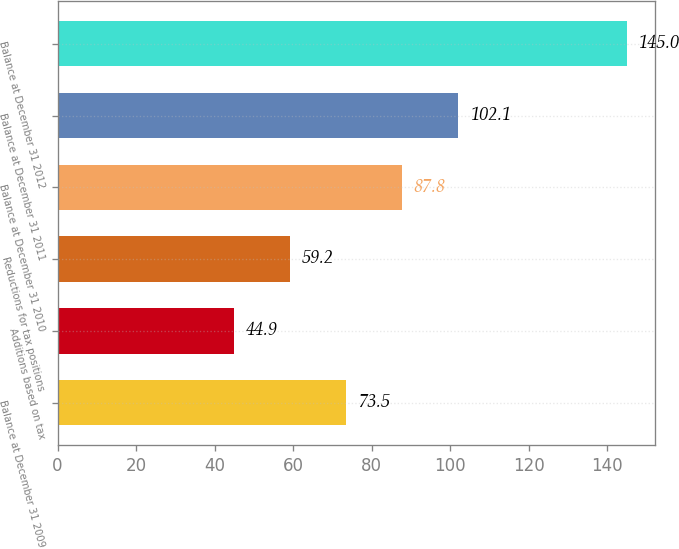Convert chart to OTSL. <chart><loc_0><loc_0><loc_500><loc_500><bar_chart><fcel>Balance at December 31 2009<fcel>Additions based on tax<fcel>Reductions for tax positions<fcel>Balance at December 31 2010<fcel>Balance at December 31 2011<fcel>Balance at December 31 2012<nl><fcel>73.5<fcel>44.9<fcel>59.2<fcel>87.8<fcel>102.1<fcel>145<nl></chart> 